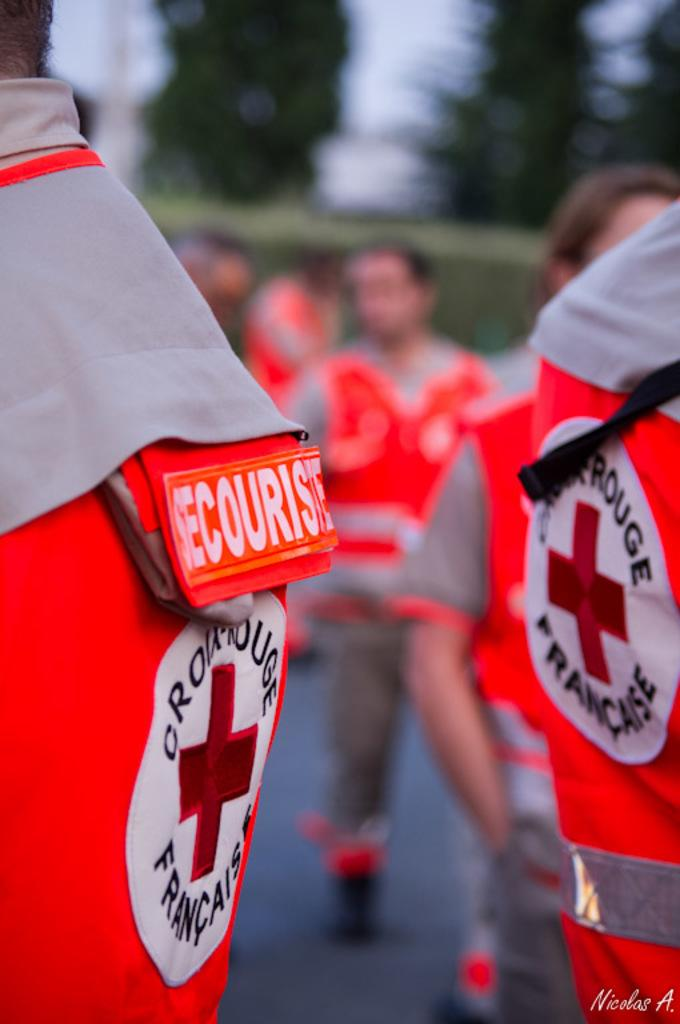Who or what is present in the image? There are people in the image. What are the people wearing? The people are wearing orange color uniforms. What can be seen in the background of the image? There are trees in the background of the image. What type of scarf is the expert wearing during breakfast in the image? There is no scarf, expert, or breakfast present in the image. 